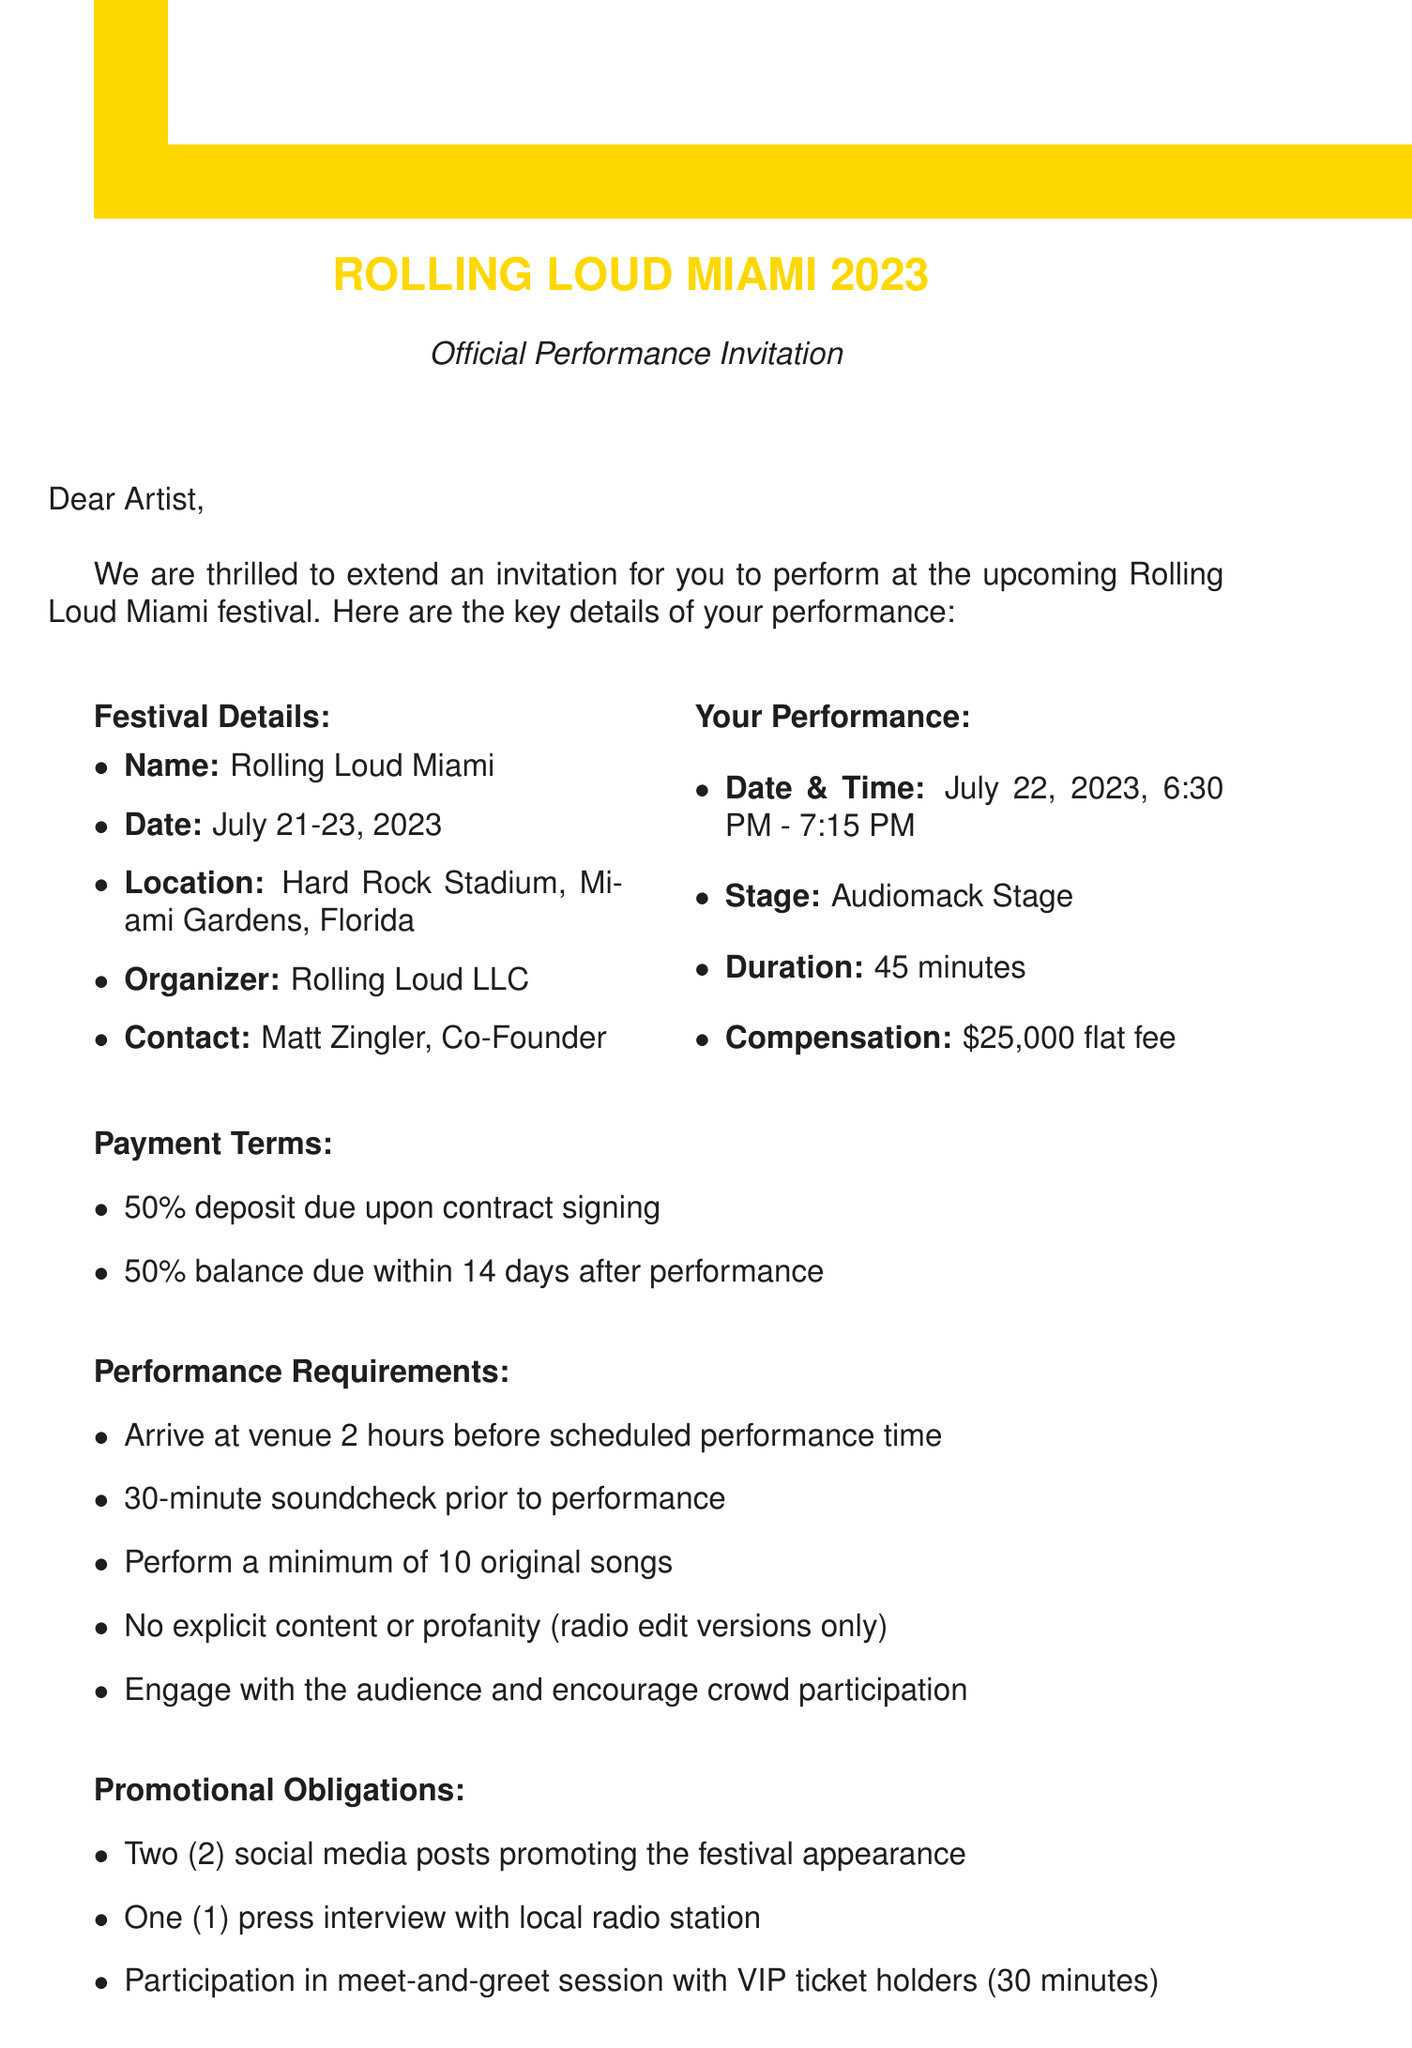What is the name of the festival? The name of the festival is explicitly stated in the document's introduction.
Answer: Rolling Loud Miami What are the festival dates? The document specifies the dates of the festival in the details section.
Answer: July 21-23, 2023 What is the compensation for the performance? The compensation amount is clearly mentioned under the performance details.
Answer: $25,000 flat fee How long is the performance slot? The duration of the performance can be found in the performance details section of the document.
Answer: 45 minutes What are the social media obligations? The document outlines the promotional obligations that include social media activity.
Answer: Two social media posts What is the exclusivity clause? The document specifies the conditions under the exclusivity clause, requiring reasoning from the content provided.
Answer: Artist agrees not to perform within a 100-mile radius of Miami for 30 days before and after the festival date What is required for the soundcheck? The requirements for soundcheck are listed in the performance requirements section.
Answer: 30-minute soundcheck prior to performance What documentation must the artist provide? The insurance requirements in the document detail what the artist needs to provide.
Answer: Proof of general liability insurance with a minimum coverage of $1,000,000 What can the artist sell during the festival? The merchandise agreement section specifies what the artist is allowed to sell.
Answer: Merchandise at designated booth What happens if the artist cancels the performance? The document includes a cancellation policy outlining consequences for cancellation by the artist.
Answer: 50% of the fee must be returned to the organizer 